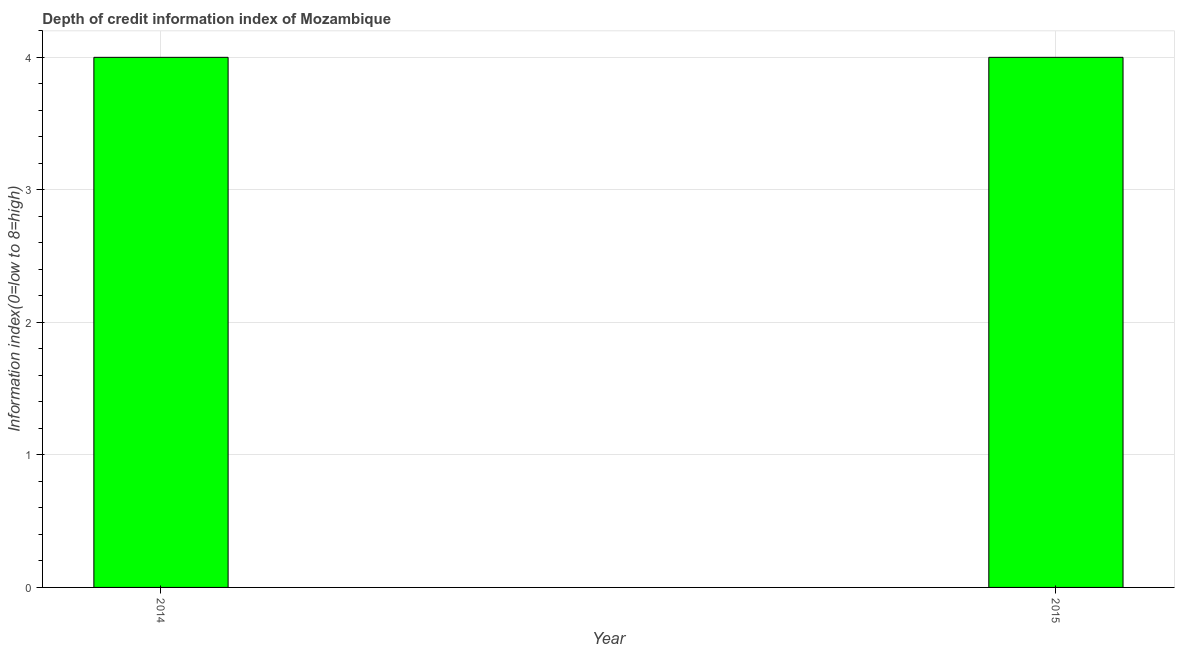Does the graph contain any zero values?
Ensure brevity in your answer.  No. What is the title of the graph?
Offer a very short reply. Depth of credit information index of Mozambique. What is the label or title of the Y-axis?
Give a very brief answer. Information index(0=low to 8=high). Across all years, what is the maximum depth of credit information index?
Provide a short and direct response. 4. Across all years, what is the minimum depth of credit information index?
Keep it short and to the point. 4. In which year was the depth of credit information index minimum?
Offer a very short reply. 2014. What is the sum of the depth of credit information index?
Your response must be concise. 8. What is the average depth of credit information index per year?
Your response must be concise. 4. In how many years, is the depth of credit information index greater than 1.6 ?
Provide a succinct answer. 2. Do a majority of the years between 2015 and 2014 (inclusive) have depth of credit information index greater than 0.8 ?
Offer a very short reply. No. What is the ratio of the depth of credit information index in 2014 to that in 2015?
Provide a succinct answer. 1. In how many years, is the depth of credit information index greater than the average depth of credit information index taken over all years?
Your response must be concise. 0. Are all the bars in the graph horizontal?
Provide a short and direct response. No. What is the difference between two consecutive major ticks on the Y-axis?
Ensure brevity in your answer.  1. What is the Information index(0=low to 8=high) in 2014?
Provide a succinct answer. 4. What is the difference between the Information index(0=low to 8=high) in 2014 and 2015?
Ensure brevity in your answer.  0. 